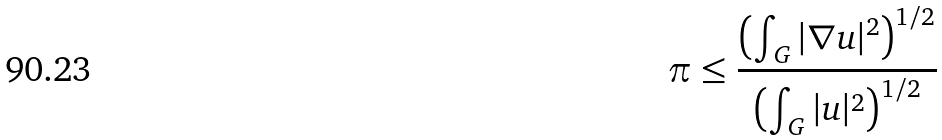<formula> <loc_0><loc_0><loc_500><loc_500>\pi \leq { \frac { \left ( \int _ { G } | \nabla u | ^ { 2 } \right ) ^ { 1 / 2 } } { \left ( \int _ { G } | u | ^ { 2 } \right ) ^ { 1 / 2 } } }</formula> 